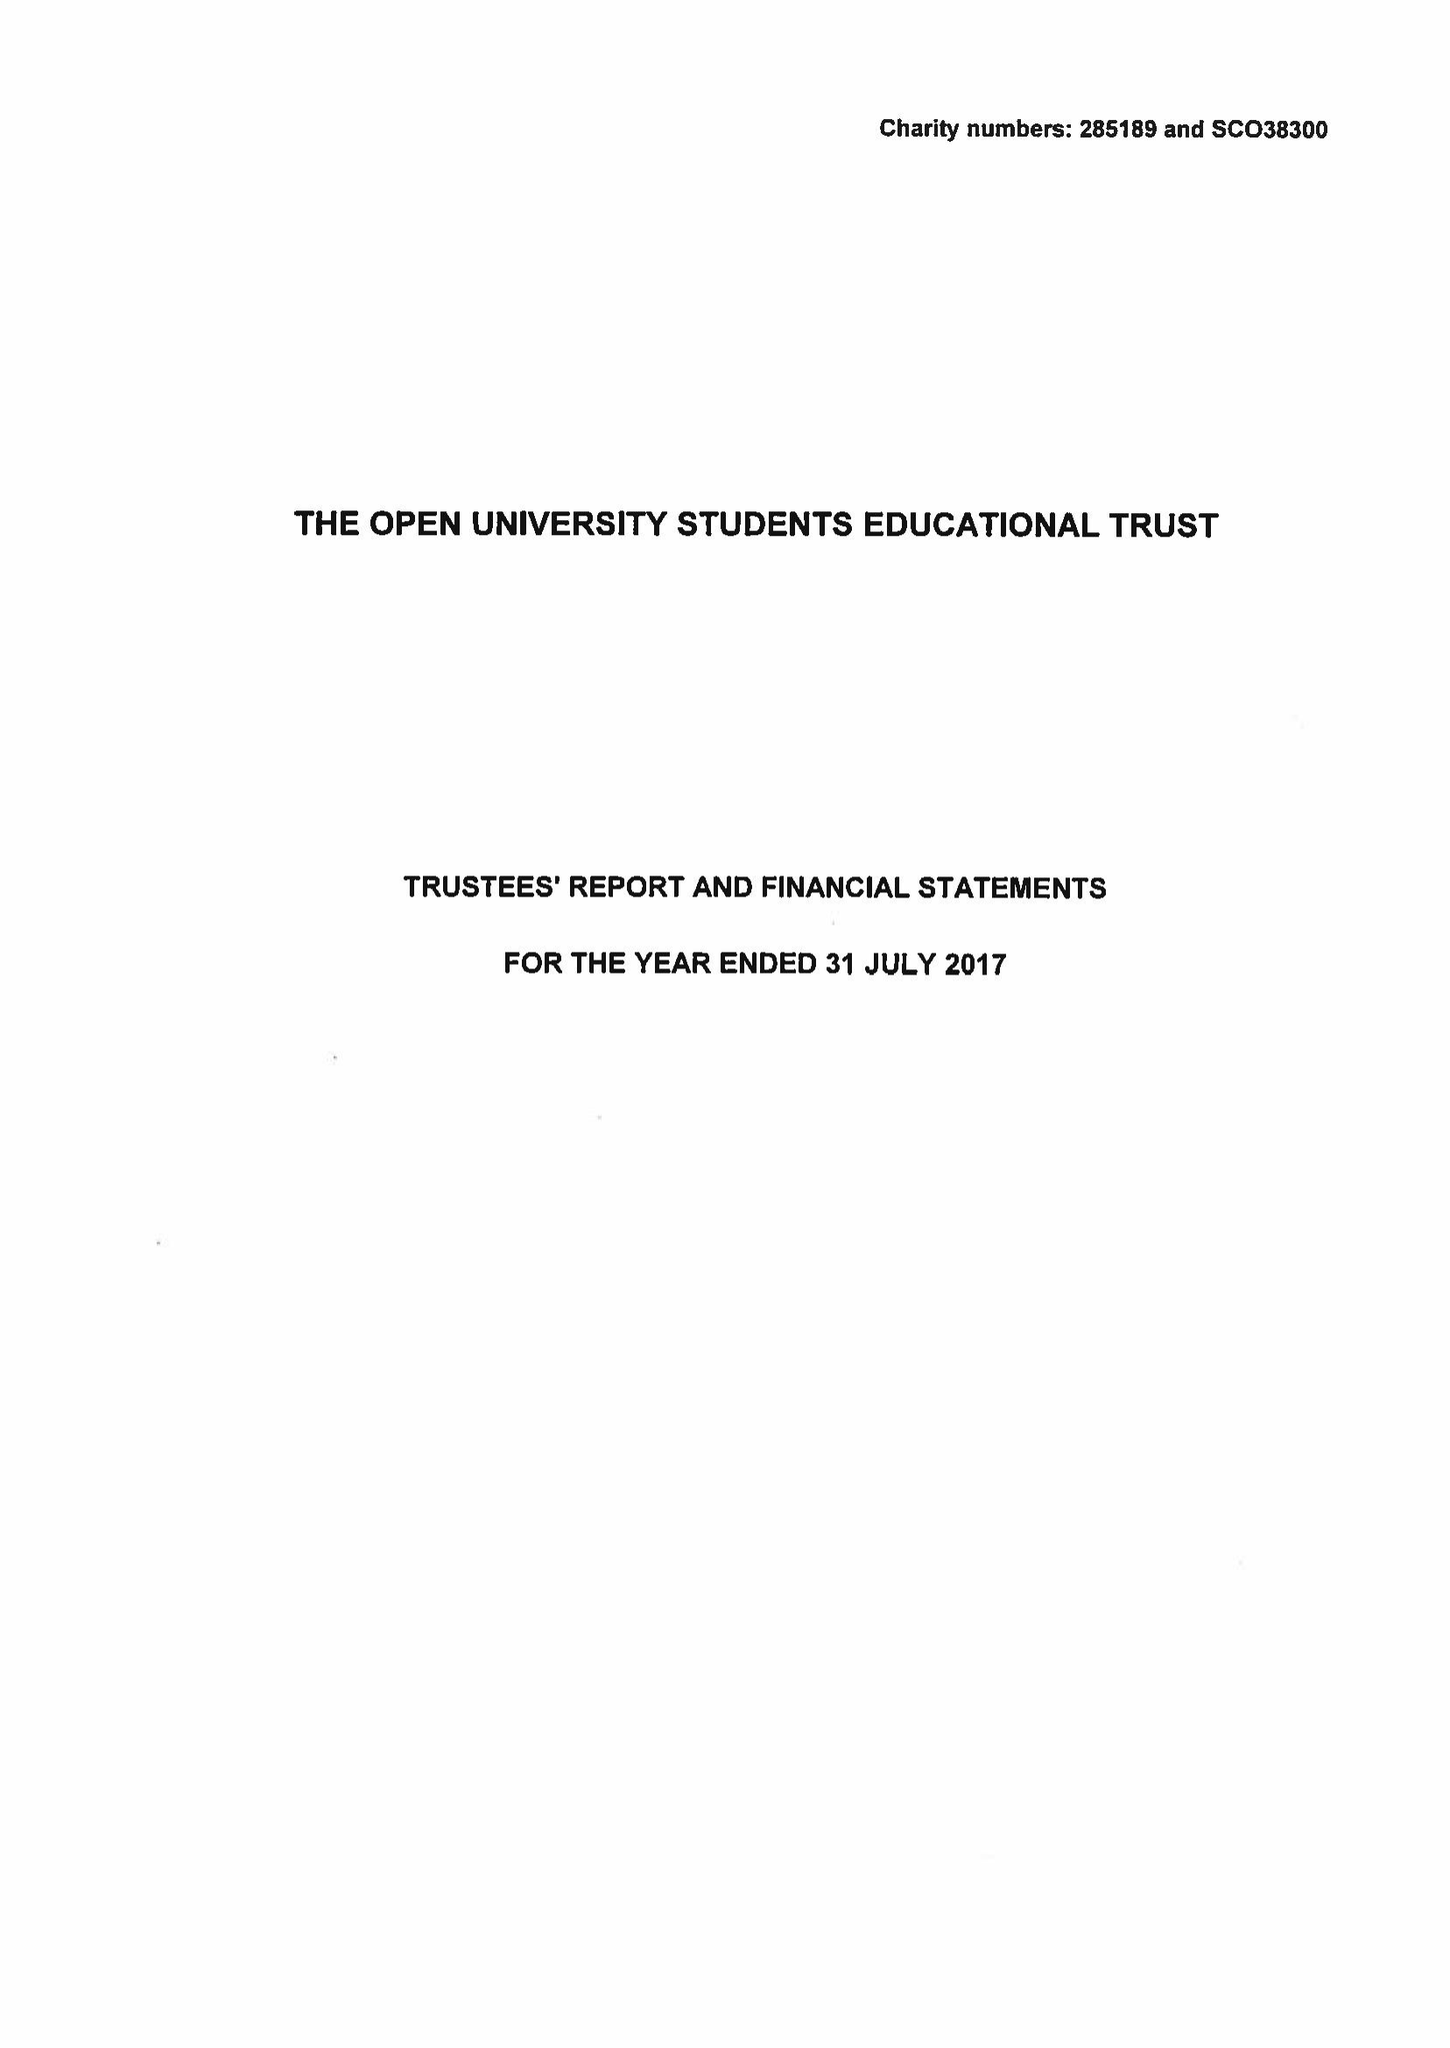What is the value for the charity_name?
Answer the question using a single word or phrase. The Open University Students' Educational Trust 